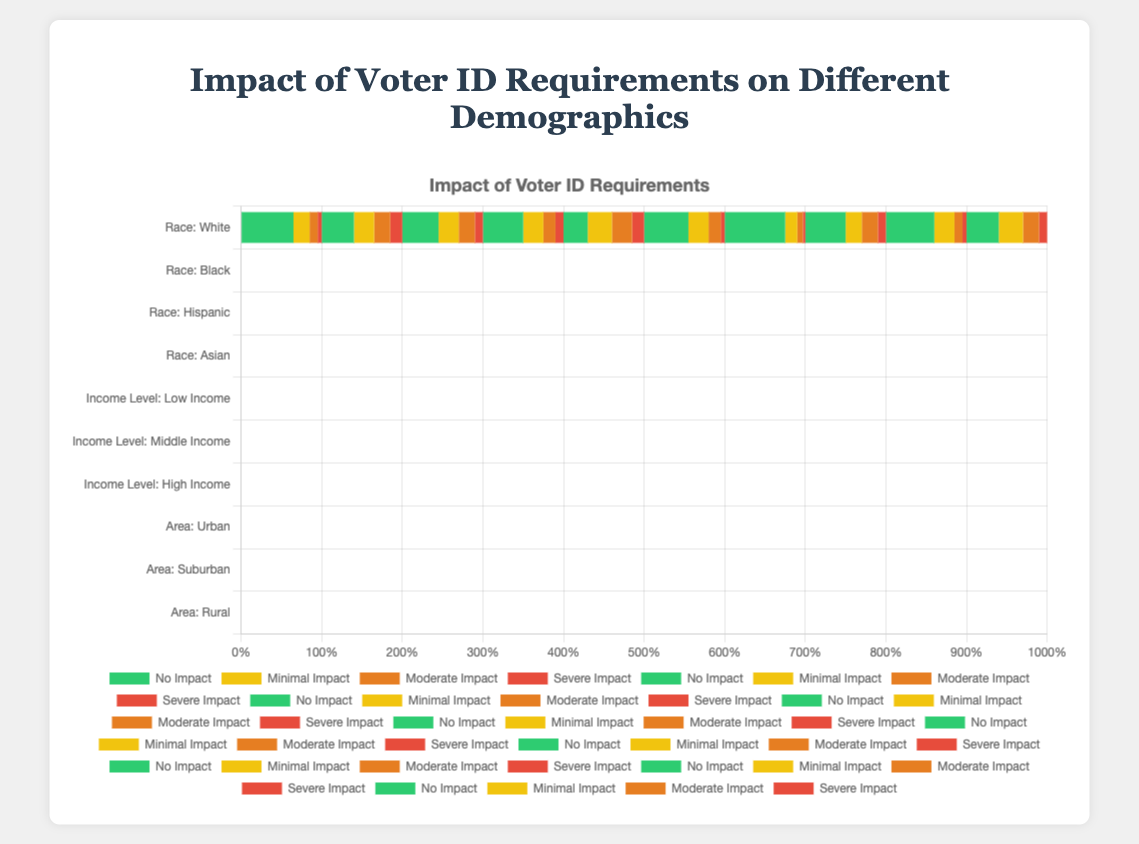What percentage of Black individuals experience either a moderate or severe impact from voter ID requirements? To find this, add the percentage of Black individuals who experience a moderate impact (20%) to those who experience a severe impact (15%). The total is 20% + 15% = 35%.
Answer: 35% Which group, Urban or Suburban, sees a greater percentage of individuals with minimal impact from voter ID requirements? Compare the percentage of Urban individuals with minimal impact (20%) to the percentage of Suburban individuals with minimal impact (25%). Suburban individuals have a higher percentage.
Answer: Suburban Among the different income levels, which group has the lowest percentage of individuals experiencing severe impact from voter ID requirements? Compare the severe impact percentages: Low Income (15%), Middle Income (5%), and High Income (3%). High Income has the lowest percentage.
Answer: High Income What is the combined percentage of Asian individuals who experience either no impact or minimal impact from voter ID requirements? Add the no impact (50%) and minimal impact (25%) percentages for Asian individuals: 50% + 25% = 75%.
Answer: 75% Which demographic category has the highest percentage of individuals experiencing no impact from voter ID requirements? Compare the highest "No Impact" percentages across all demographics: 
White (65%), 
Black (40%), 
Hispanic (45%), 
Asian (50%), 
Low Income (30%), 
Middle Income (55%), 
High Income (75%), 
Urban (50%), 
Suburban (60%), 
Rural (40%). 
High Income individuals have the highest percentage.
Answer: High Income Is the percentage of Rural individuals experiencing minimal impact greater than or less than the percentage of Low Income individuals with the same level of impact? Compare the minimal impact percentages: Rural (30%) and Low Income (30%). They are equal.
Answer: Equal What is the difference in the percentage of White individuals and Hispanic individuals that experience no impact from voter ID requirements? Subtract the "No Impact" percentage for Hispanic individuals (45%) from the "No Impact" percentage for White individuals (65%): 65% - 45% = 20%.
Answer: 20% How does the percentage of Black individuals with severe impact compare to the percentage of White individuals with severe impact from voter ID requirements? Compare the "Severe Impact" percentages: Black individuals (15%) and White individuals (5%). The percentage for Black individuals is higher.
Answer: Black individuals have a higher percentage What is the total percentage impact (adding no impact, minimal impact, moderate impact, and severe impact) for Suburban individuals? The total percentage for any demographic should be 100% as it's a stacked bar chart implying the sum of all impacts equals 100%.
Answer: 100% Which demographic (Urban, Suburban, or Rural) has the smallest percentage of individuals experiencing a moderate impact from voter ID requirements? Compare the "Moderate Impact" percentages: Urban (20%), Suburban (10%), Rural (20%). Suburban has the smallest percentage.
Answer: Suburban 